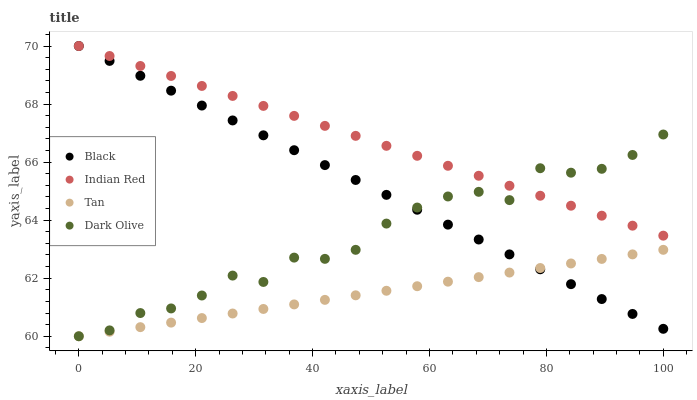Does Tan have the minimum area under the curve?
Answer yes or no. Yes. Does Indian Red have the maximum area under the curve?
Answer yes or no. Yes. Does Dark Olive have the minimum area under the curve?
Answer yes or no. No. Does Dark Olive have the maximum area under the curve?
Answer yes or no. No. Is Tan the smoothest?
Answer yes or no. Yes. Is Dark Olive the roughest?
Answer yes or no. Yes. Is Black the smoothest?
Answer yes or no. No. Is Black the roughest?
Answer yes or no. No. Does Tan have the lowest value?
Answer yes or no. Yes. Does Black have the lowest value?
Answer yes or no. No. Does Indian Red have the highest value?
Answer yes or no. Yes. Does Dark Olive have the highest value?
Answer yes or no. No. Is Tan less than Indian Red?
Answer yes or no. Yes. Is Indian Red greater than Tan?
Answer yes or no. Yes. Does Indian Red intersect Dark Olive?
Answer yes or no. Yes. Is Indian Red less than Dark Olive?
Answer yes or no. No. Is Indian Red greater than Dark Olive?
Answer yes or no. No. Does Tan intersect Indian Red?
Answer yes or no. No. 